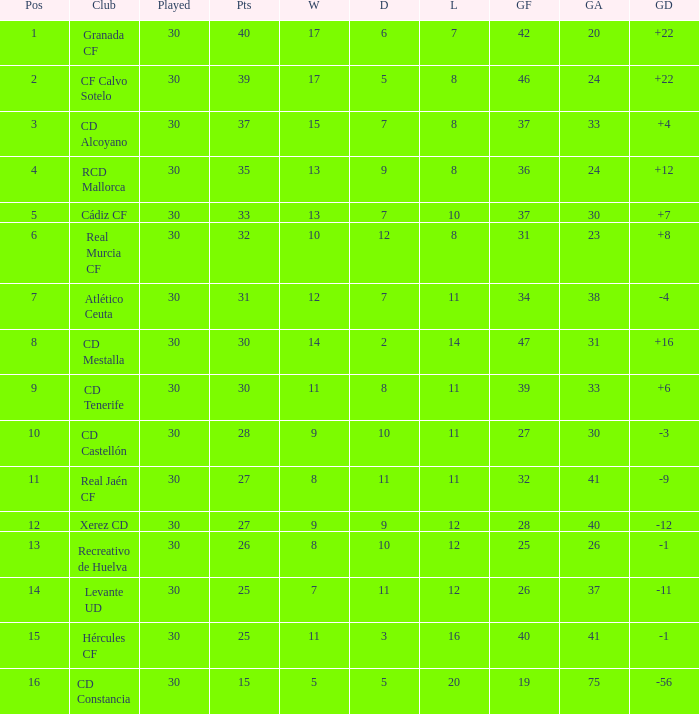How many Wins have Goals against smaller than 30, and Goals for larger than 25, and Draws larger than 5? 3.0. 